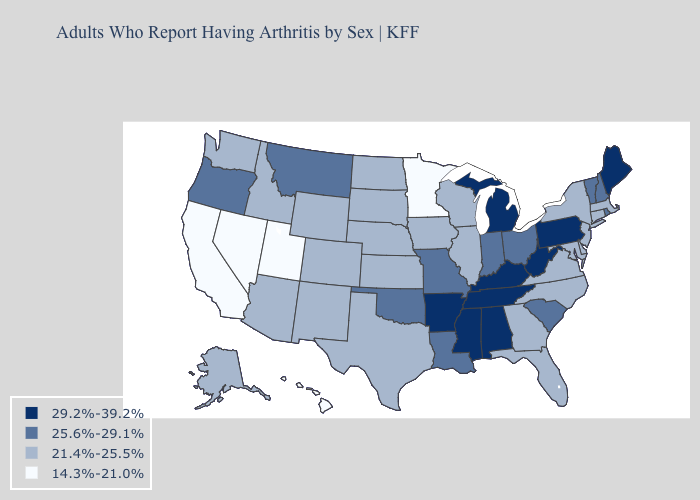Name the states that have a value in the range 25.6%-29.1%?
Be succinct. Indiana, Louisiana, Missouri, Montana, New Hampshire, Ohio, Oklahoma, Oregon, Rhode Island, South Carolina, Vermont. What is the value of Wyoming?
Be succinct. 21.4%-25.5%. Does California have the lowest value in the West?
Quick response, please. Yes. Does the map have missing data?
Answer briefly. No. Name the states that have a value in the range 21.4%-25.5%?
Quick response, please. Alaska, Arizona, Colorado, Connecticut, Delaware, Florida, Georgia, Idaho, Illinois, Iowa, Kansas, Maryland, Massachusetts, Nebraska, New Jersey, New Mexico, New York, North Carolina, North Dakota, South Dakota, Texas, Virginia, Washington, Wisconsin, Wyoming. Name the states that have a value in the range 21.4%-25.5%?
Short answer required. Alaska, Arizona, Colorado, Connecticut, Delaware, Florida, Georgia, Idaho, Illinois, Iowa, Kansas, Maryland, Massachusetts, Nebraska, New Jersey, New Mexico, New York, North Carolina, North Dakota, South Dakota, Texas, Virginia, Washington, Wisconsin, Wyoming. What is the value of Mississippi?
Keep it brief. 29.2%-39.2%. Name the states that have a value in the range 21.4%-25.5%?
Short answer required. Alaska, Arizona, Colorado, Connecticut, Delaware, Florida, Georgia, Idaho, Illinois, Iowa, Kansas, Maryland, Massachusetts, Nebraska, New Jersey, New Mexico, New York, North Carolina, North Dakota, South Dakota, Texas, Virginia, Washington, Wisconsin, Wyoming. Which states have the lowest value in the West?
Answer briefly. California, Hawaii, Nevada, Utah. What is the value of Wyoming?
Keep it brief. 21.4%-25.5%. What is the value of Nebraska?
Quick response, please. 21.4%-25.5%. What is the lowest value in the MidWest?
Short answer required. 14.3%-21.0%. Does Florida have the highest value in the South?
Quick response, please. No. What is the value of Arizona?
Give a very brief answer. 21.4%-25.5%. What is the value of Connecticut?
Be succinct. 21.4%-25.5%. 